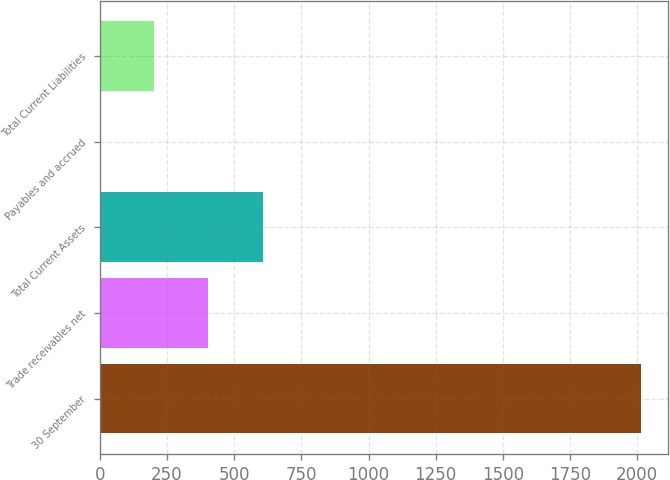Convert chart to OTSL. <chart><loc_0><loc_0><loc_500><loc_500><bar_chart><fcel>30 September<fcel>Trade receivables net<fcel>Total Current Assets<fcel>Payables and accrued<fcel>Total Current Liabilities<nl><fcel>2013<fcel>404.52<fcel>605.58<fcel>2.4<fcel>203.46<nl></chart> 